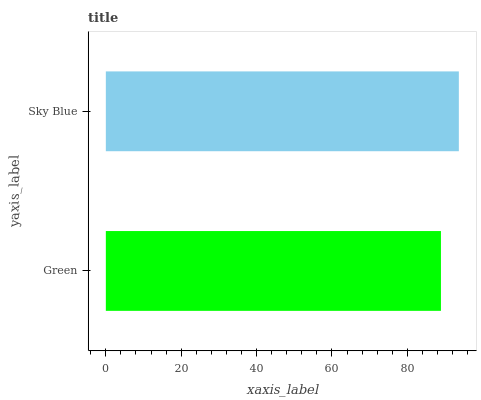Is Green the minimum?
Answer yes or no. Yes. Is Sky Blue the maximum?
Answer yes or no. Yes. Is Sky Blue the minimum?
Answer yes or no. No. Is Sky Blue greater than Green?
Answer yes or no. Yes. Is Green less than Sky Blue?
Answer yes or no. Yes. Is Green greater than Sky Blue?
Answer yes or no. No. Is Sky Blue less than Green?
Answer yes or no. No. Is Sky Blue the high median?
Answer yes or no. Yes. Is Green the low median?
Answer yes or no. Yes. Is Green the high median?
Answer yes or no. No. Is Sky Blue the low median?
Answer yes or no. No. 